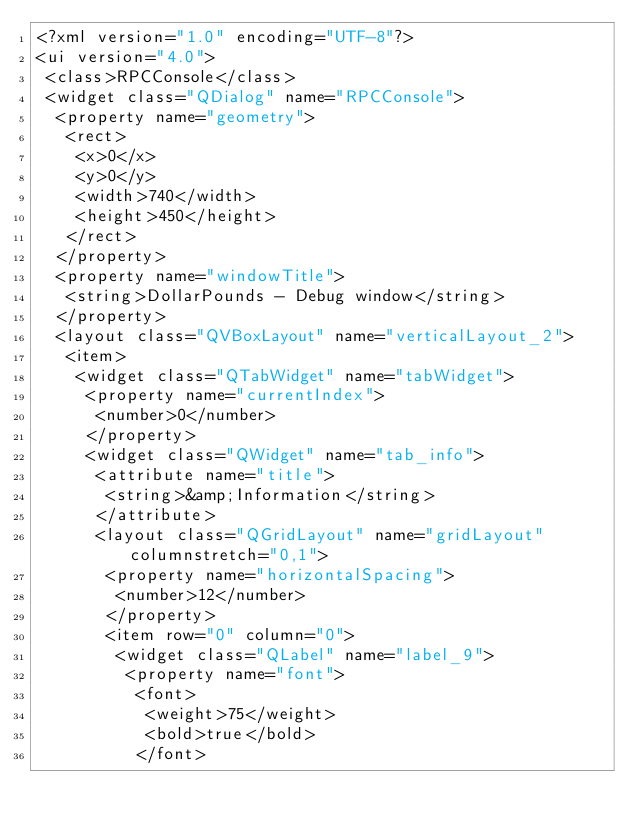<code> <loc_0><loc_0><loc_500><loc_500><_XML_><?xml version="1.0" encoding="UTF-8"?>
<ui version="4.0">
 <class>RPCConsole</class>
 <widget class="QDialog" name="RPCConsole">
  <property name="geometry">
   <rect>
    <x>0</x>
    <y>0</y>
    <width>740</width>
    <height>450</height>
   </rect>
  </property>
  <property name="windowTitle">
   <string>DollarPounds - Debug window</string>
  </property>
  <layout class="QVBoxLayout" name="verticalLayout_2">
   <item>
    <widget class="QTabWidget" name="tabWidget">
     <property name="currentIndex">
      <number>0</number>
     </property>
     <widget class="QWidget" name="tab_info">
      <attribute name="title">
       <string>&amp;Information</string>
      </attribute>
      <layout class="QGridLayout" name="gridLayout" columnstretch="0,1">
       <property name="horizontalSpacing">
        <number>12</number>
       </property>
       <item row="0" column="0">
        <widget class="QLabel" name="label_9">
         <property name="font">
          <font>
           <weight>75</weight>
           <bold>true</bold>
          </font></code> 